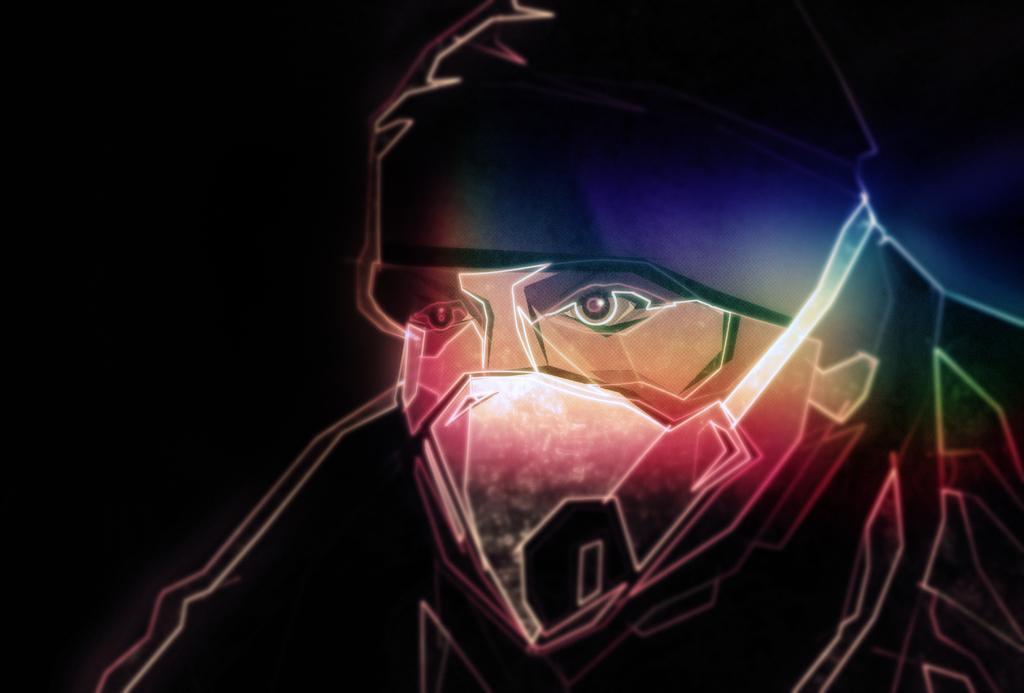Can you describe this image briefly? This is an animated picture of a man and I can see dark background. 